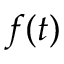<formula> <loc_0><loc_0><loc_500><loc_500>f ( t )</formula> 